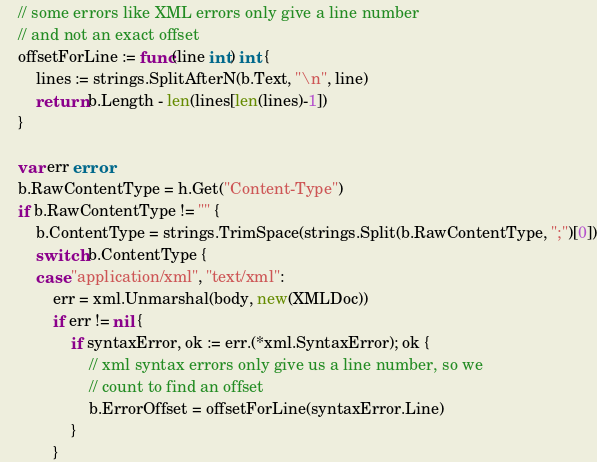Convert code to text. <code><loc_0><loc_0><loc_500><loc_500><_Go_>	// some errors like XML errors only give a line number
	// and not an exact offset
	offsetForLine := func(line int) int {
		lines := strings.SplitAfterN(b.Text, "\n", line)
		return b.Length - len(lines[len(lines)-1])
	}

	var err error
	b.RawContentType = h.Get("Content-Type")
	if b.RawContentType != "" {
		b.ContentType = strings.TrimSpace(strings.Split(b.RawContentType, ";")[0])
		switch b.ContentType {
		case "application/xml", "text/xml":
			err = xml.Unmarshal(body, new(XMLDoc))
			if err != nil {
				if syntaxError, ok := err.(*xml.SyntaxError); ok {
					// xml syntax errors only give us a line number, so we
					// count to find an offset
					b.ErrorOffset = offsetForLine(syntaxError.Line)
				}
			}
</code> 